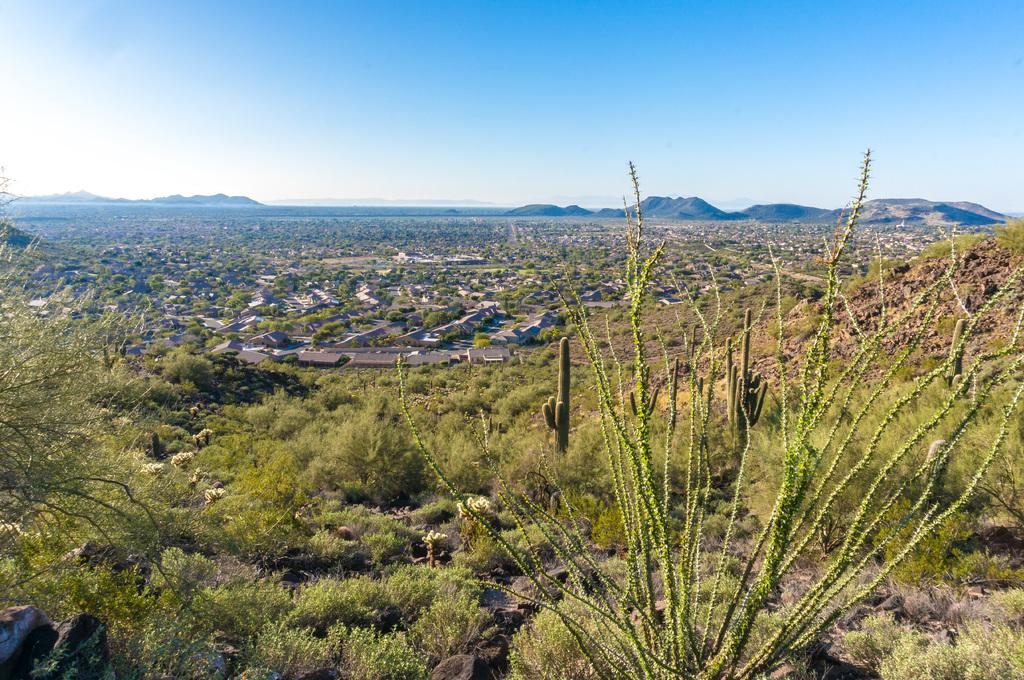What can be seen in the background of the image? The sky and hills are visible in the background of the image. What type of structures are present in the image? There are houses in the image. What part of the houses can be seen in the image? Rooftops are present in the image. What type of vegetation is visible in the image? Trees and plants are visible in the image. What type of event is taking place in the image? There is no event taking place in the image; it is a static scene featuring houses, rooftops, trees, and plants. Can you tell me how many servants are visible in the image? There are no servants present in the image. 